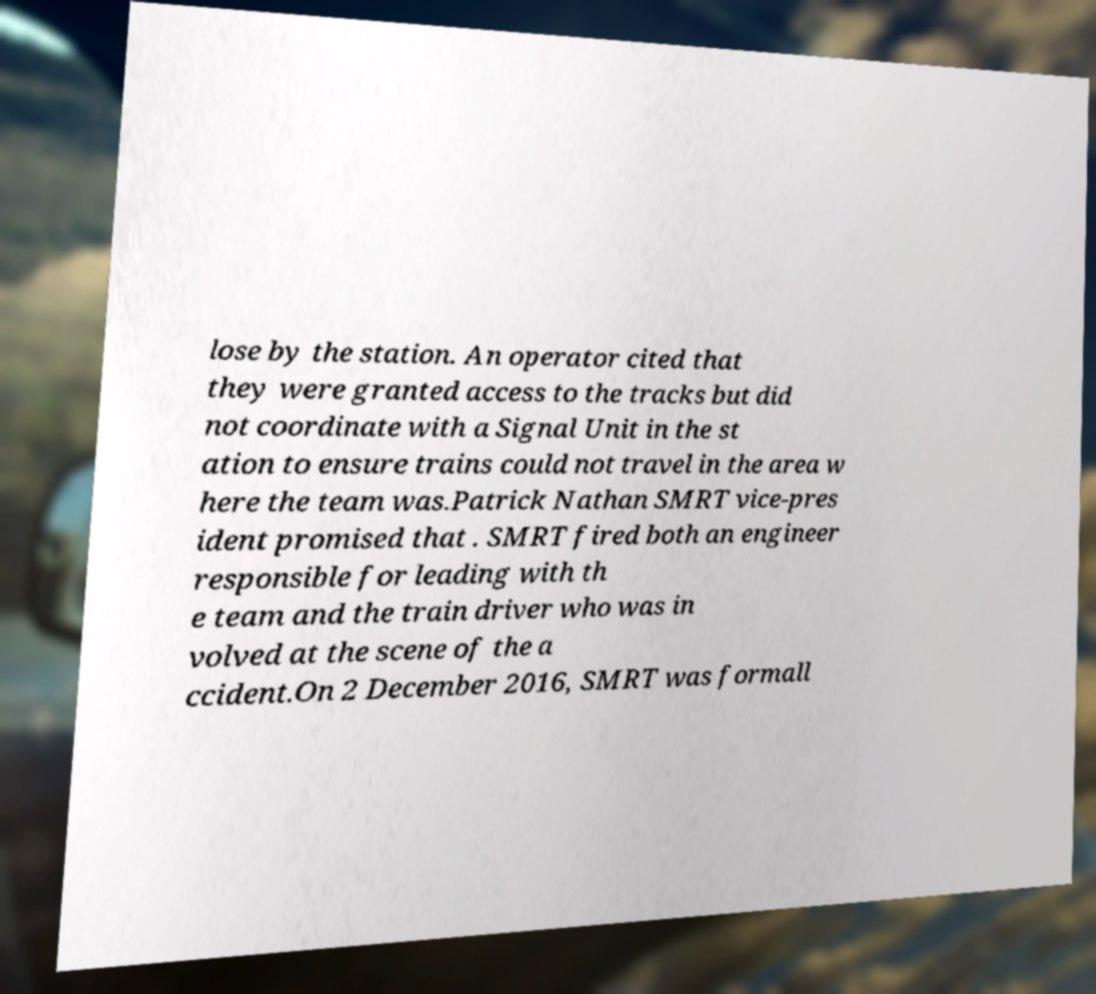What messages or text are displayed in this image? I need them in a readable, typed format. lose by the station. An operator cited that they were granted access to the tracks but did not coordinate with a Signal Unit in the st ation to ensure trains could not travel in the area w here the team was.Patrick Nathan SMRT vice-pres ident promised that . SMRT fired both an engineer responsible for leading with th e team and the train driver who was in volved at the scene of the a ccident.On 2 December 2016, SMRT was formall 